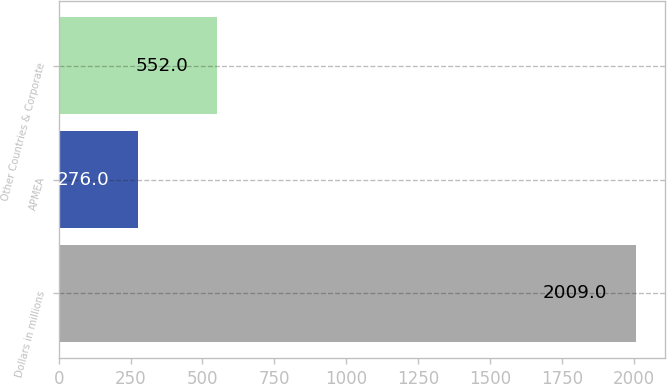Convert chart to OTSL. <chart><loc_0><loc_0><loc_500><loc_500><bar_chart><fcel>Dollars in millions<fcel>APMEA<fcel>Other Countries & Corporate<nl><fcel>2009<fcel>276<fcel>552<nl></chart> 